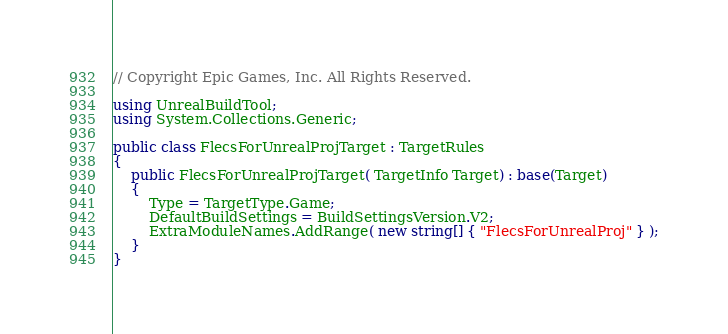Convert code to text. <code><loc_0><loc_0><loc_500><loc_500><_C#_>// Copyright Epic Games, Inc. All Rights Reserved.

using UnrealBuildTool;
using System.Collections.Generic;

public class FlecsForUnrealProjTarget : TargetRules
{
	public FlecsForUnrealProjTarget( TargetInfo Target) : base(Target)
	{
		Type = TargetType.Game;
		DefaultBuildSettings = BuildSettingsVersion.V2;
		ExtraModuleNames.AddRange( new string[] { "FlecsForUnrealProj" } );
	}
}
</code> 